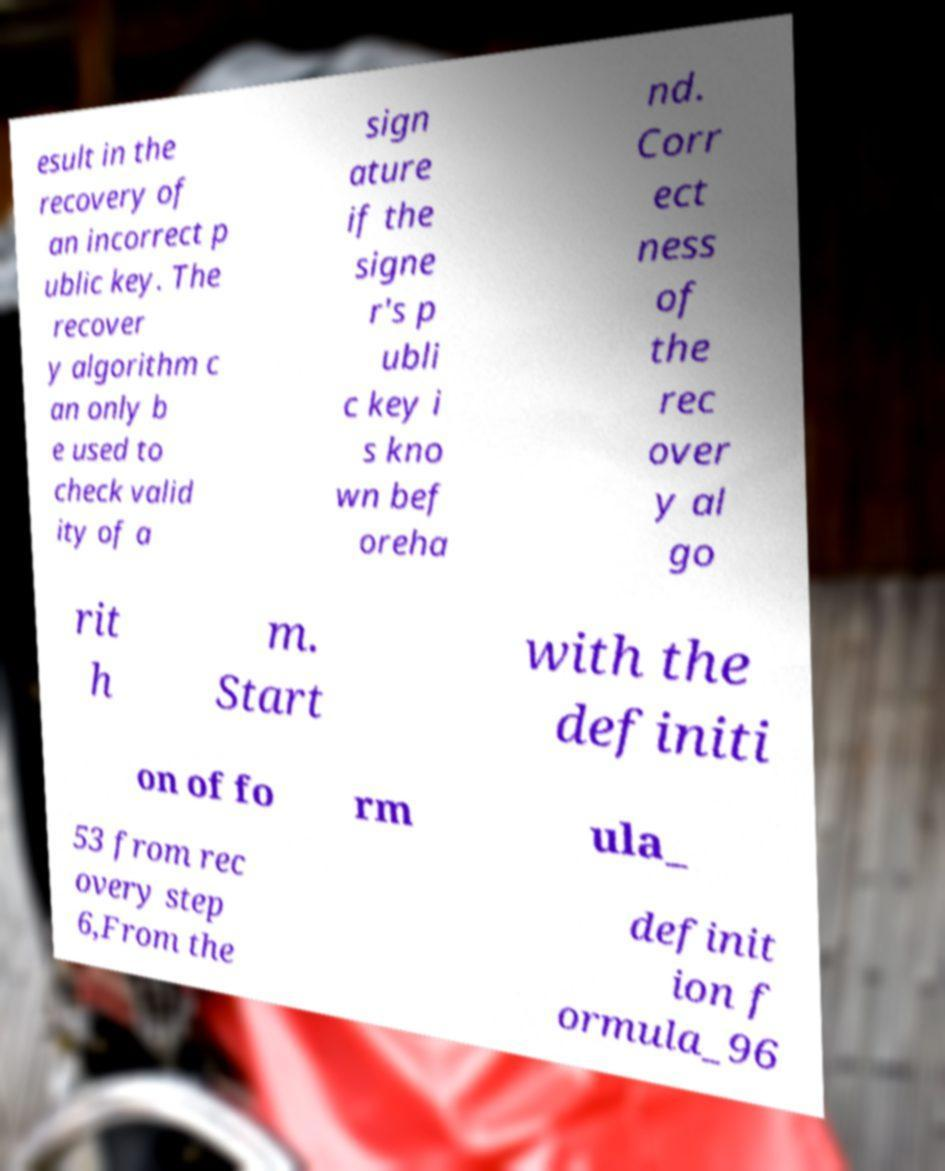There's text embedded in this image that I need extracted. Can you transcribe it verbatim? esult in the recovery of an incorrect p ublic key. The recover y algorithm c an only b e used to check valid ity of a sign ature if the signe r's p ubli c key i s kno wn bef oreha nd. Corr ect ness of the rec over y al go rit h m. Start with the definiti on of fo rm ula_ 53 from rec overy step 6,From the definit ion f ormula_96 